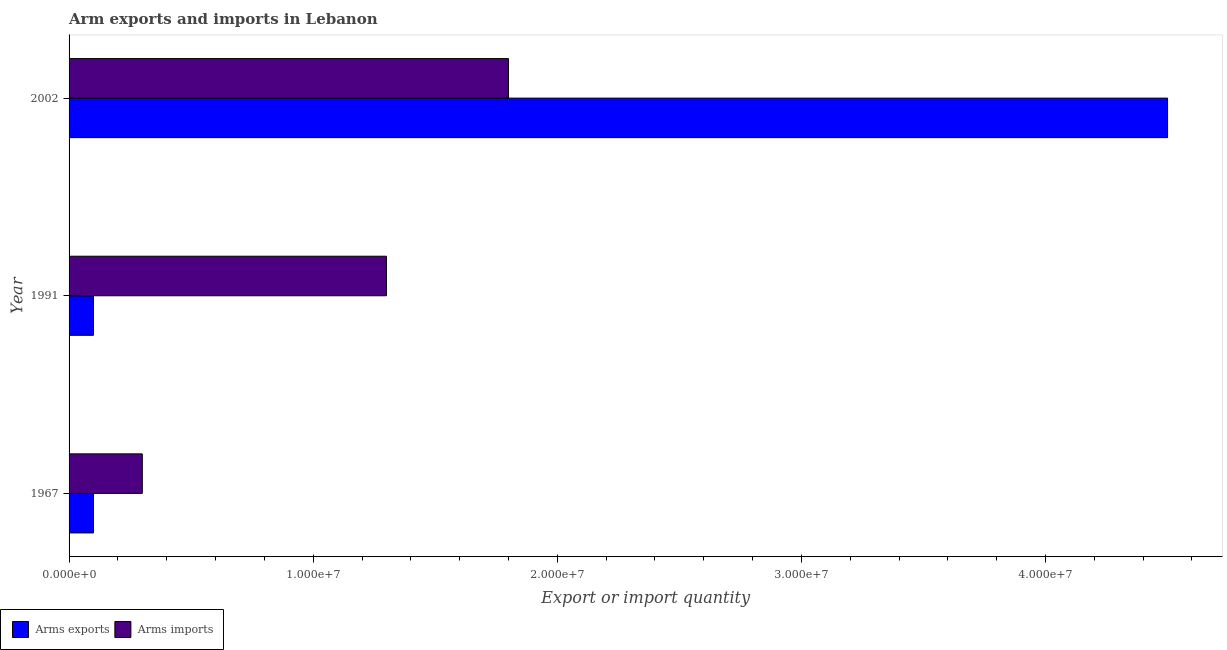How many groups of bars are there?
Your answer should be very brief. 3. How many bars are there on the 1st tick from the top?
Your answer should be very brief. 2. How many bars are there on the 2nd tick from the bottom?
Offer a terse response. 2. What is the arms exports in 1967?
Your answer should be compact. 1.00e+06. Across all years, what is the maximum arms imports?
Your response must be concise. 1.80e+07. Across all years, what is the minimum arms exports?
Make the answer very short. 1.00e+06. In which year was the arms imports minimum?
Keep it short and to the point. 1967. What is the total arms imports in the graph?
Your answer should be very brief. 3.40e+07. What is the difference between the arms imports in 1967 and that in 1991?
Offer a very short reply. -1.00e+07. What is the difference between the arms imports in 2002 and the arms exports in 1967?
Offer a terse response. 1.70e+07. What is the average arms imports per year?
Your response must be concise. 1.13e+07. In the year 1991, what is the difference between the arms imports and arms exports?
Your answer should be very brief. 1.20e+07. What is the ratio of the arms exports in 1991 to that in 2002?
Make the answer very short. 0.02. Is the arms imports in 1991 less than that in 2002?
Give a very brief answer. Yes. Is the difference between the arms exports in 1967 and 1991 greater than the difference between the arms imports in 1967 and 1991?
Make the answer very short. Yes. What is the difference between the highest and the second highest arms imports?
Your answer should be very brief. 5.00e+06. What is the difference between the highest and the lowest arms exports?
Ensure brevity in your answer.  4.40e+07. In how many years, is the arms imports greater than the average arms imports taken over all years?
Offer a very short reply. 2. Is the sum of the arms exports in 1991 and 2002 greater than the maximum arms imports across all years?
Your answer should be compact. Yes. What does the 1st bar from the top in 2002 represents?
Give a very brief answer. Arms imports. What does the 1st bar from the bottom in 1967 represents?
Provide a short and direct response. Arms exports. Are all the bars in the graph horizontal?
Your answer should be very brief. Yes. How many years are there in the graph?
Offer a very short reply. 3. Are the values on the major ticks of X-axis written in scientific E-notation?
Ensure brevity in your answer.  Yes. Does the graph contain any zero values?
Provide a short and direct response. No. How many legend labels are there?
Your answer should be compact. 2. How are the legend labels stacked?
Give a very brief answer. Horizontal. What is the title of the graph?
Provide a succinct answer. Arm exports and imports in Lebanon. Does "Exports of goods" appear as one of the legend labels in the graph?
Your answer should be very brief. No. What is the label or title of the X-axis?
Provide a short and direct response. Export or import quantity. What is the Export or import quantity of Arms exports in 1991?
Provide a short and direct response. 1.00e+06. What is the Export or import quantity in Arms imports in 1991?
Make the answer very short. 1.30e+07. What is the Export or import quantity of Arms exports in 2002?
Ensure brevity in your answer.  4.50e+07. What is the Export or import quantity in Arms imports in 2002?
Make the answer very short. 1.80e+07. Across all years, what is the maximum Export or import quantity in Arms exports?
Make the answer very short. 4.50e+07. Across all years, what is the maximum Export or import quantity of Arms imports?
Make the answer very short. 1.80e+07. What is the total Export or import quantity in Arms exports in the graph?
Provide a succinct answer. 4.70e+07. What is the total Export or import quantity of Arms imports in the graph?
Ensure brevity in your answer.  3.40e+07. What is the difference between the Export or import quantity in Arms imports in 1967 and that in 1991?
Make the answer very short. -1.00e+07. What is the difference between the Export or import quantity of Arms exports in 1967 and that in 2002?
Offer a terse response. -4.40e+07. What is the difference between the Export or import quantity of Arms imports in 1967 and that in 2002?
Your answer should be very brief. -1.50e+07. What is the difference between the Export or import quantity of Arms exports in 1991 and that in 2002?
Ensure brevity in your answer.  -4.40e+07. What is the difference between the Export or import quantity in Arms imports in 1991 and that in 2002?
Offer a very short reply. -5.00e+06. What is the difference between the Export or import quantity of Arms exports in 1967 and the Export or import quantity of Arms imports in 1991?
Give a very brief answer. -1.20e+07. What is the difference between the Export or import quantity of Arms exports in 1967 and the Export or import quantity of Arms imports in 2002?
Offer a terse response. -1.70e+07. What is the difference between the Export or import quantity in Arms exports in 1991 and the Export or import quantity in Arms imports in 2002?
Ensure brevity in your answer.  -1.70e+07. What is the average Export or import quantity in Arms exports per year?
Offer a very short reply. 1.57e+07. What is the average Export or import quantity of Arms imports per year?
Your response must be concise. 1.13e+07. In the year 1967, what is the difference between the Export or import quantity in Arms exports and Export or import quantity in Arms imports?
Offer a very short reply. -2.00e+06. In the year 1991, what is the difference between the Export or import quantity in Arms exports and Export or import quantity in Arms imports?
Make the answer very short. -1.20e+07. In the year 2002, what is the difference between the Export or import quantity of Arms exports and Export or import quantity of Arms imports?
Your answer should be compact. 2.70e+07. What is the ratio of the Export or import quantity in Arms imports in 1967 to that in 1991?
Provide a short and direct response. 0.23. What is the ratio of the Export or import quantity in Arms exports in 1967 to that in 2002?
Ensure brevity in your answer.  0.02. What is the ratio of the Export or import quantity in Arms imports in 1967 to that in 2002?
Your response must be concise. 0.17. What is the ratio of the Export or import quantity in Arms exports in 1991 to that in 2002?
Offer a very short reply. 0.02. What is the ratio of the Export or import quantity of Arms imports in 1991 to that in 2002?
Your answer should be compact. 0.72. What is the difference between the highest and the second highest Export or import quantity of Arms exports?
Your answer should be compact. 4.40e+07. What is the difference between the highest and the lowest Export or import quantity in Arms exports?
Offer a very short reply. 4.40e+07. What is the difference between the highest and the lowest Export or import quantity in Arms imports?
Your answer should be compact. 1.50e+07. 